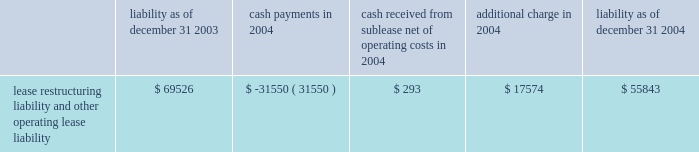The activity related to the restructuring liability for 2004 is as follows ( in thousands ) : non-operating items interest income increased $ 1.7 million to $ 12.0 million in 2005 from $ 10.3 million in 2004 .
The increase was mainly the result of higher returns on invested funds .
Interest expense decreased $ 1.0 million , or 5% ( 5 % ) , to $ 17.3 million in 2005 from $ 18.3 million in 2004 as a result of the exchange of newly issued stock for a portion of our outstanding convertible debt in the second half of 2005 .
In addition , as a result of the issuance during 2005 of common stock in exchange for convertible subordinated notes , we recorded a non- cash charge of $ 48.2 million .
This charge related to the incremental shares issued in the transactions over the number of shares that would have been issued upon the conversion of the notes under their original terms .
Liquidity and capital resources we have incurred operating losses since our inception and historically have financed our operations principally through public and private offerings of our equity and debt securities , strategic collaborative agreements that include research and/or development funding , development milestones and royalties on the sales of products , investment income and proceeds from the issuance of stock under our employee benefit programs .
At december 31 , 2006 , we had cash , cash equivalents and marketable securities of $ 761.8 million , which was an increase of $ 354.2 million from $ 407.5 million at december 31 , 2005 .
The increase was primarily a result of : 2022 $ 313.7 million in net proceeds from our september 2006 public offering of common stock ; 2022 $ 165.0 million from an up-front payment we received in connection with signing the janssen agreement ; 2022 $ 52.4 million from the issuance of common stock under our employee benefit plans ; and 2022 $ 30.0 million from the sale of shares of altus pharmaceuticals inc .
Common stock and warrants to purchase altus common stock .
These cash inflows were partially offset by the significant cash expenditures we made in 2006 related to research and development expenses and sales , general and administrative expenses .
Capital expenditures for property and equipment during 2006 were $ 32.4 million .
At december 31 , 2006 , we had $ 42.1 million in aggregate principal amount of the 2007 notes and $ 59.6 million in aggregate principal amount of the 2011 notes outstanding .
The 2007 notes are due in september 2007 and are convertible into common stock at the option of the holder at a price equal to $ 92.26 per share , subject to adjustment under certain circumstances .
In february 2007 , we announced that we will redeem our 2011 notes on march 5 , 2007 .
The 2011 notes are convertible into shares of our common stock at the option of the holder at a price equal to $ 14.94 per share .
We expect the holders of the 2011 notes will elect to convert their notes into stock , in which case we will issue approximately 4.0 million .
We will be required to repay any 2011 notes that are not converted at the rate of $ 1003.19 per $ 1000 principal amount , which includes principal and interest that will accrue to the redemption date .
Liability as of december 31 , payments in 2004 cash received from sublease , net of operating costs in 2004 additional charge in liability as of december 31 , lease restructuring liability and other operating lease liability $ 69526 $ ( 31550 ) $ 293 $ 17574 $ 55843 .
The activity related to the restructuring liability for 2004 is as follows ( in thousands ) : non-operating items interest income increased $ 1.7 million to $ 12.0 million in 2005 from $ 10.3 million in 2004 .
The increase was mainly the result of higher returns on invested funds .
Interest expense decreased $ 1.0 million , or 5% ( 5 % ) , to $ 17.3 million in 2005 from $ 18.3 million in 2004 as a result of the exchange of newly issued stock for a portion of our outstanding convertible debt in the second half of 2005 .
In addition , as a result of the issuance during 2005 of common stock in exchange for convertible subordinated notes , we recorded a non- cash charge of $ 48.2 million .
This charge related to the incremental shares issued in the transactions over the number of shares that would have been issued upon the conversion of the notes under their original terms .
Liquidity and capital resources we have incurred operating losses since our inception and historically have financed our operations principally through public and private offerings of our equity and debt securities , strategic collaborative agreements that include research and/or development funding , development milestones and royalties on the sales of products , investment income and proceeds from the issuance of stock under our employee benefit programs .
At december 31 , 2006 , we had cash , cash equivalents and marketable securities of $ 761.8 million , which was an increase of $ 354.2 million from $ 407.5 million at december 31 , 2005 .
The increase was primarily a result of : 2022 $ 313.7 million in net proceeds from our september 2006 public offering of common stock ; 2022 $ 165.0 million from an up-front payment we received in connection with signing the janssen agreement ; 2022 $ 52.4 million from the issuance of common stock under our employee benefit plans ; and 2022 $ 30.0 million from the sale of shares of altus pharmaceuticals inc .
Common stock and warrants to purchase altus common stock .
These cash inflows were partially offset by the significant cash expenditures we made in 2006 related to research and development expenses and sales , general and administrative expenses .
Capital expenditures for property and equipment during 2006 were $ 32.4 million .
At december 31 , 2006 , we had $ 42.1 million in aggregate principal amount of the 2007 notes and $ 59.6 million in aggregate principal amount of the 2011 notes outstanding .
The 2007 notes are due in september 2007 and are convertible into common stock at the option of the holder at a price equal to $ 92.26 per share , subject to adjustment under certain circumstances .
In february 2007 , we announced that we will redeem our 2011 notes on march 5 , 2007 .
The 2011 notes are convertible into shares of our common stock at the option of the holder at a price equal to $ 14.94 per share .
We expect the holders of the 2011 notes will elect to convert their notes into stock , in which case we will issue approximately 4.0 million .
We will be required to repay any 2011 notes that are not converted at the rate of $ 1003.19 per $ 1000 principal amount , which includes principal and interest that will accrue to the redemption date .
Liability as of december 31 , payments in 2004 cash received from sublease , net of operating costs in 2004 additional charge in liability as of december 31 , lease restructuring liability and other operating lease liability $ 69526 $ ( 31550 ) $ 293 $ 17574 $ 55843 .
What is the total change in liability , in dollars , between 2003 and 2004? 
Computations: (55843 - 69526)
Answer: -13683.0. 